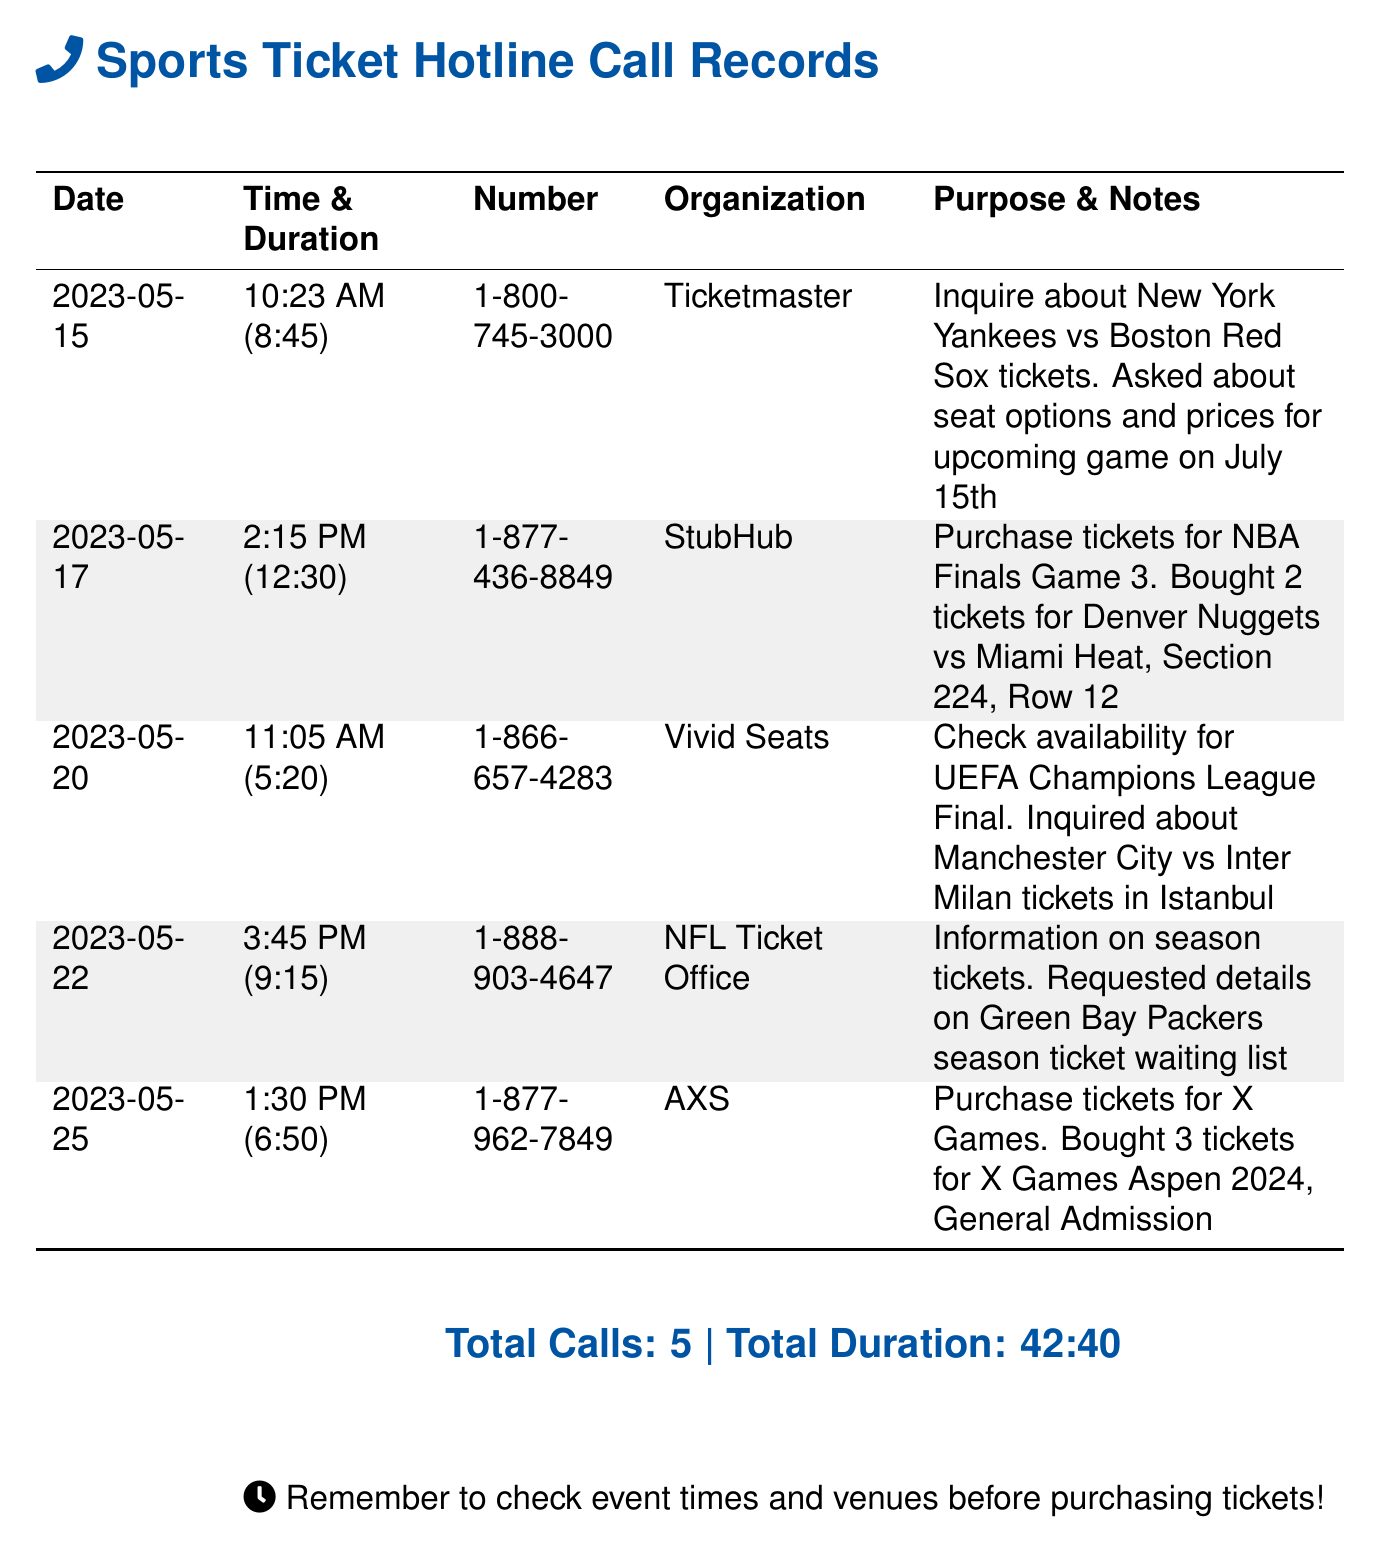What is the date of the first call? The first call was made on May 15, 2023, according to the record.
Answer: May 15, 2023 How long was the call to Ticketmaster? The duration of the call to Ticketmaster is listed as 8 minutes and 45 seconds.
Answer: 8:45 What organization was contacted for NBA Finals tickets? The ticket purchase for the NBA Finals was made through StubHub.
Answer: StubHub How many tickets were purchased for the X Games? The record shows that 3 tickets were bought for the X Games.
Answer: 3 tickets What was the purpose of the call to the NFL Ticket Office? The purpose was to request details on the Green Bay Packers season ticket waiting list.
Answer: Season tickets information What was the organization involved in purchasing tickets for the UEFA Champions League Final? The tickets for the UEFA Champions League Final were inquired about through Vivid Seats.
Answer: Vivid Seats Which game was the inquiry about when calling Ticketmaster? The inquiry was about the New York Yankees vs Boston Red Sox game.
Answer: New York Yankees vs Boston Red Sox What is the total duration of all calls? The total duration sums up to 42 minutes and 40 seconds across all calls in the document.
Answer: 42:40 How many calls were made in total? The document states that there were 5 calls made in total.
Answer: 5 